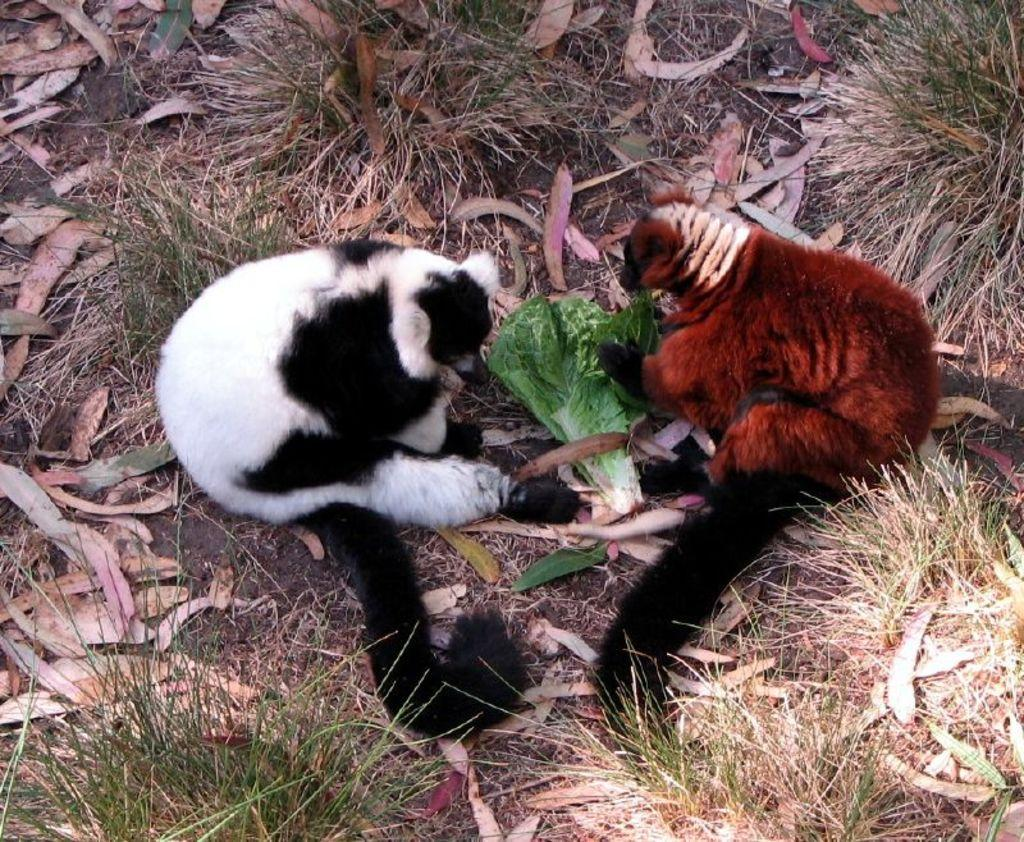What animals are present in the image? There are two Lemurs in the image. What are the Lemurs doing in the image? The Lemurs are sitting on the ground. Where are the Lemurs located in the image? The Lemurs are in the middle of the image. What type of vegetation can be seen in the image? There is grass in the corners of the image. What letter is the Lemur holding in the image? There is no letter present in the image; the Lemurs are sitting on the ground and there are no objects in their hands. 